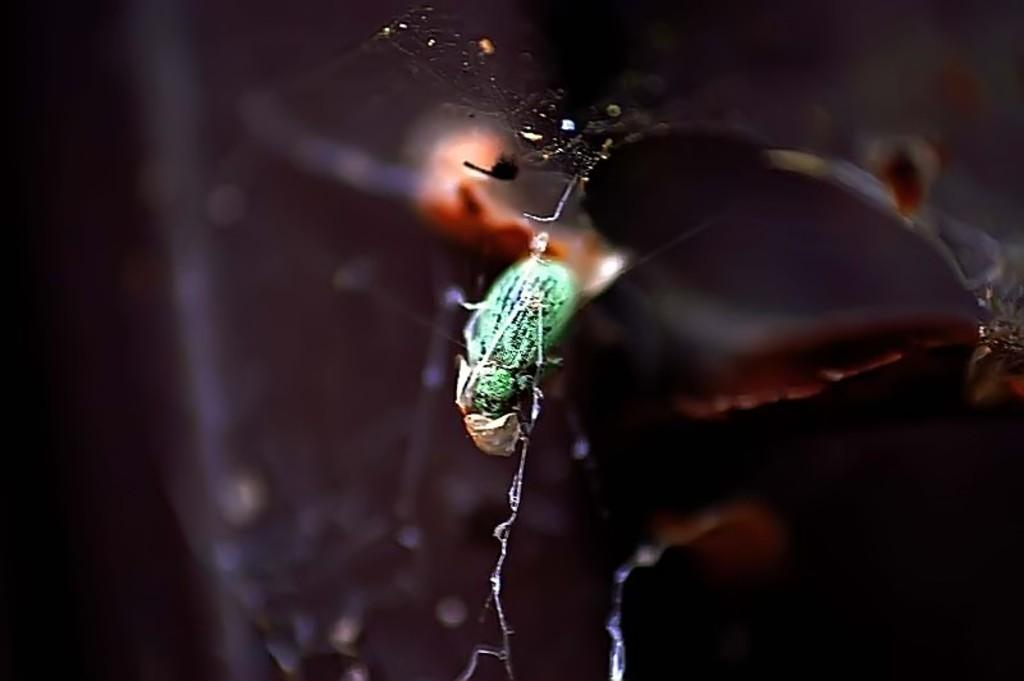What type of creature can be seen in the image? There is an insect in the image. Can you describe the background of the image? The background of the image is blurred. What type of authority does the governor have in the image? There is no governor or any indication of authority present in the image; it features an insect and a blurred background. 